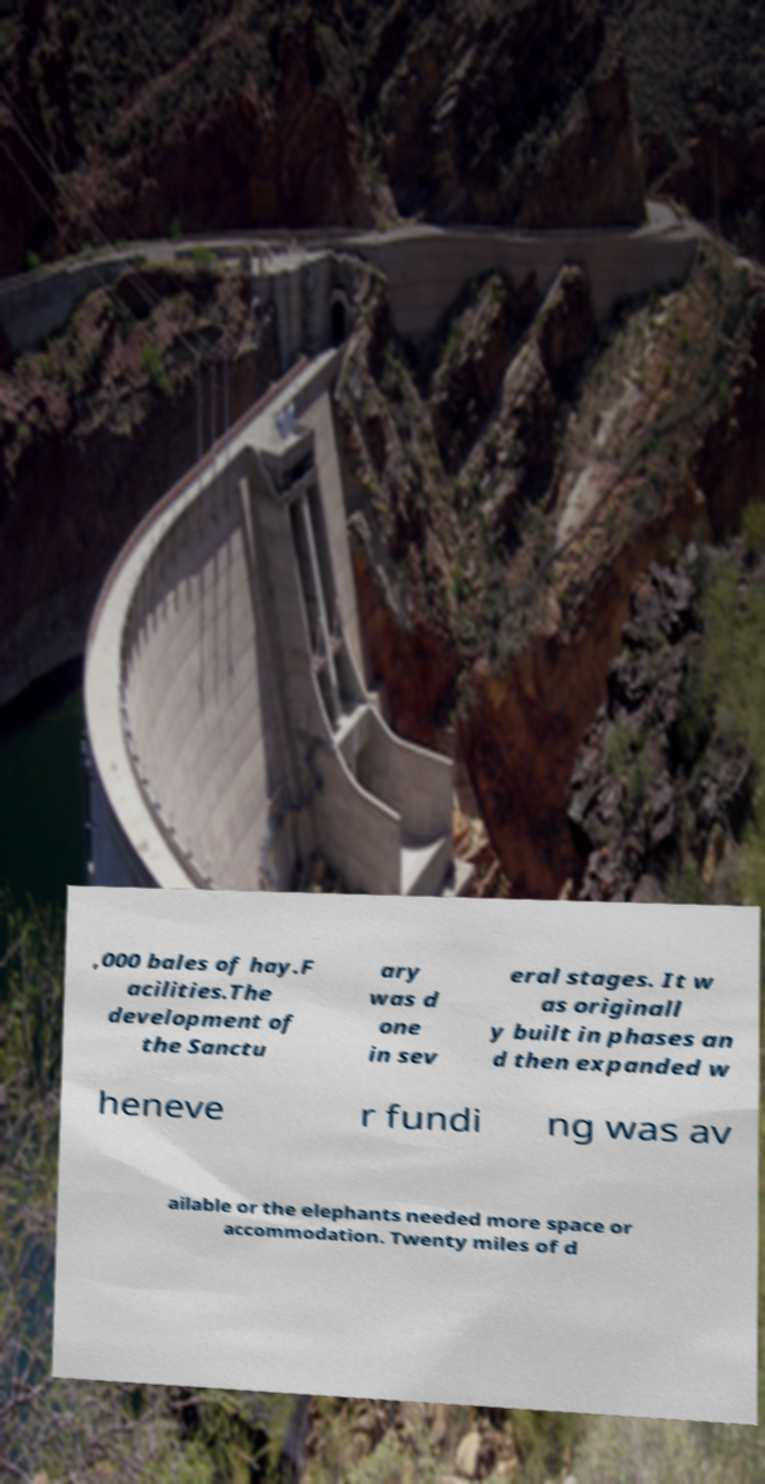For documentation purposes, I need the text within this image transcribed. Could you provide that? ,000 bales of hay.F acilities.The development of the Sanctu ary was d one in sev eral stages. It w as originall y built in phases an d then expanded w heneve r fundi ng was av ailable or the elephants needed more space or accommodation. Twenty miles of d 